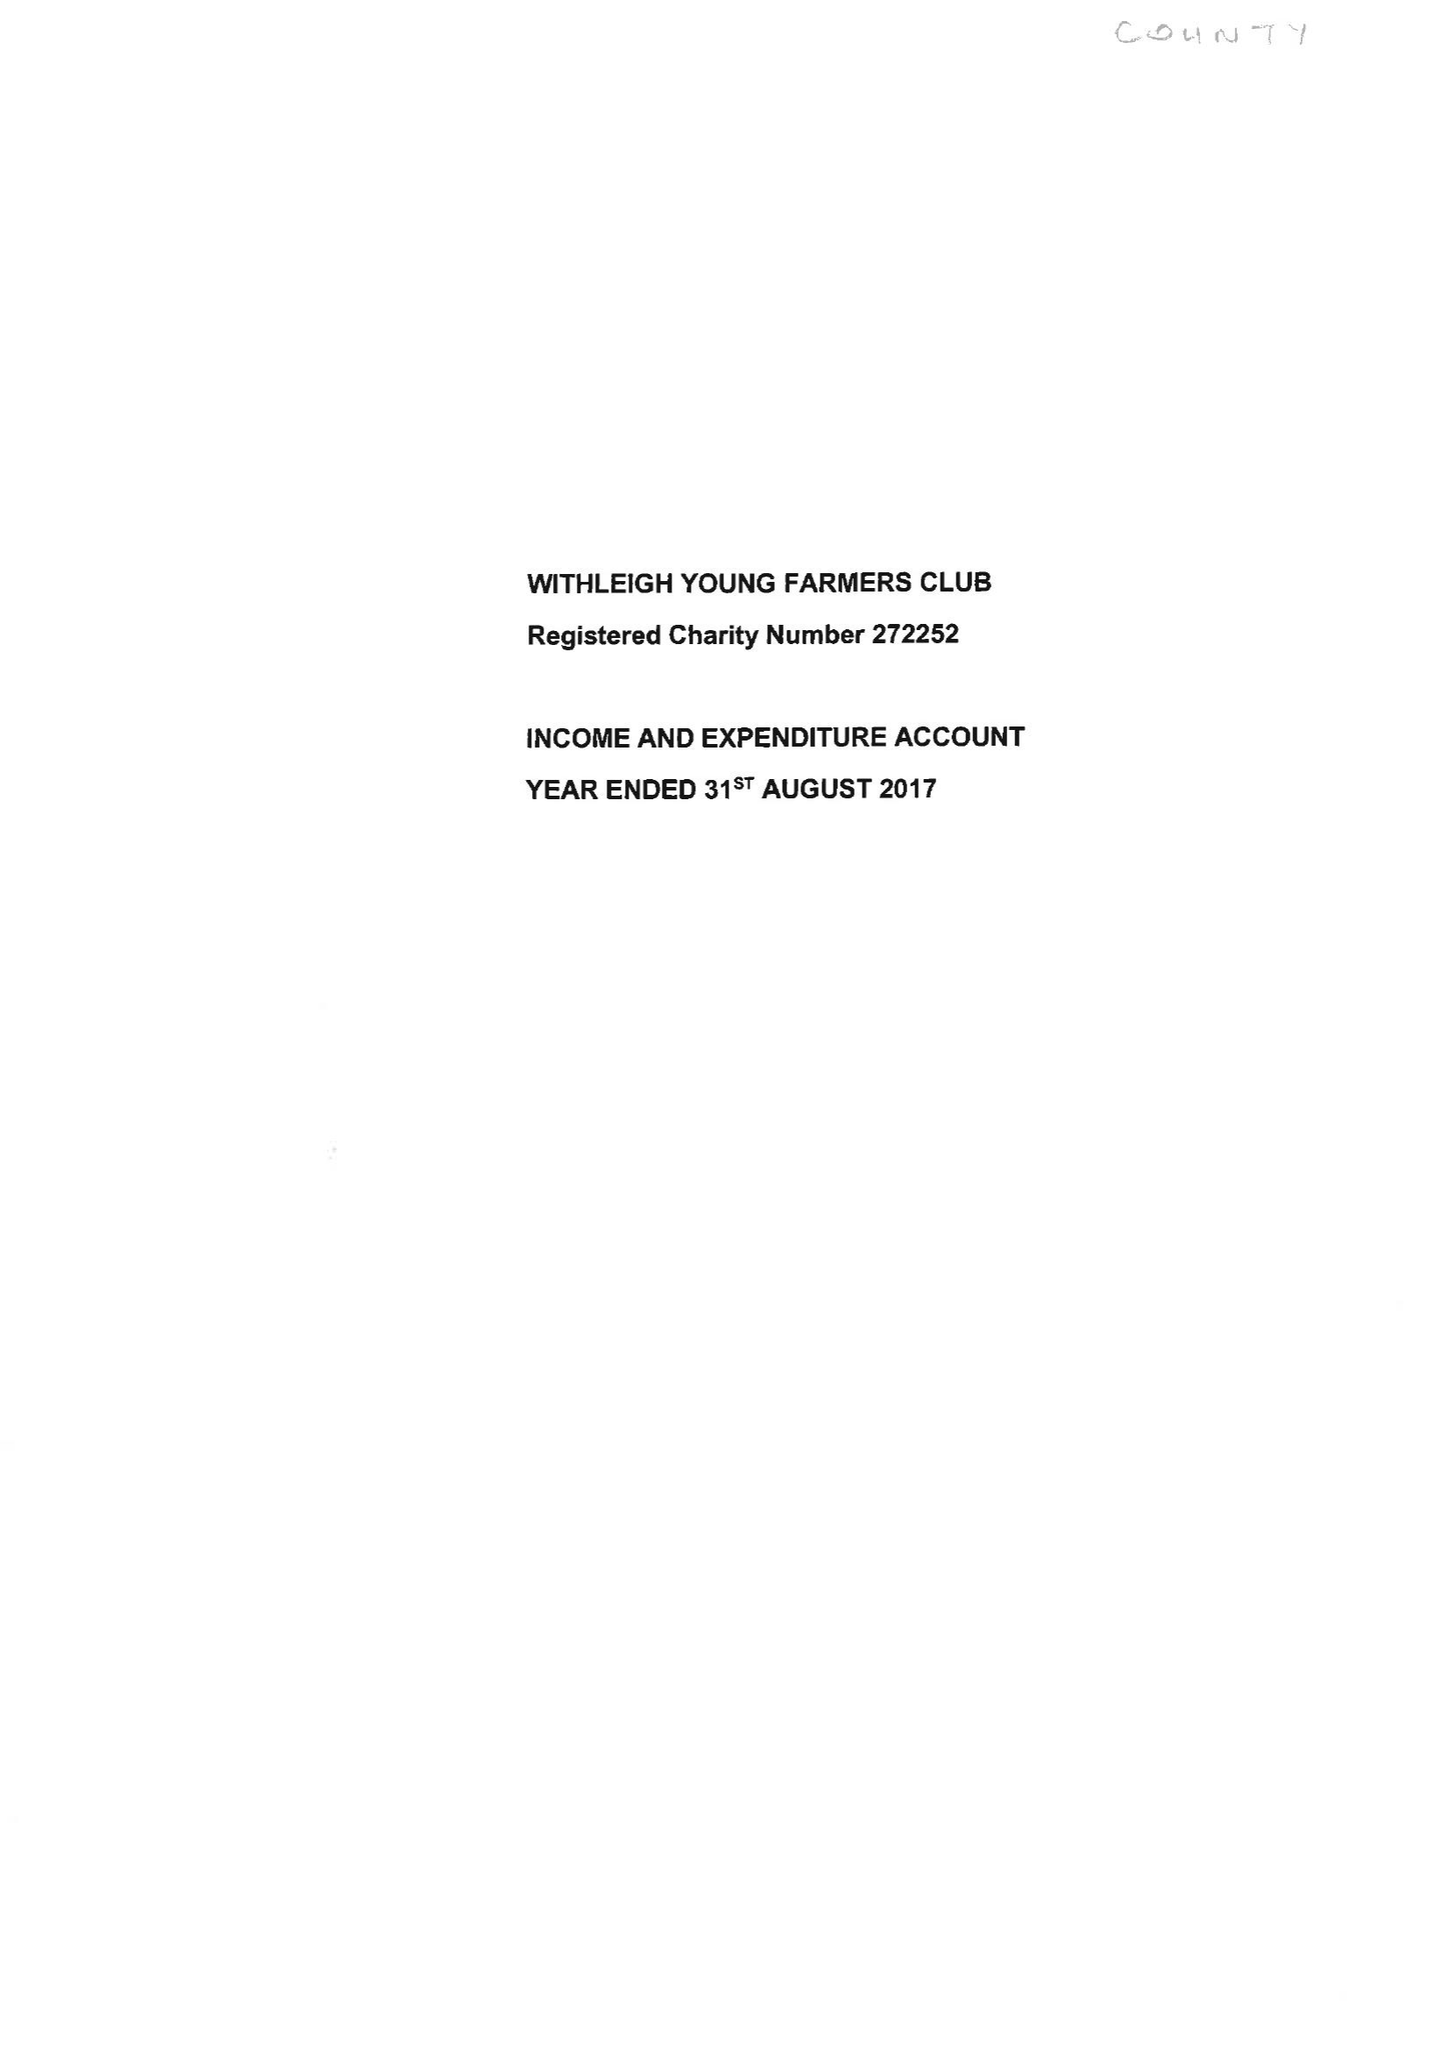What is the value for the address__post_town?
Answer the question using a single word or phrase. EXETER 